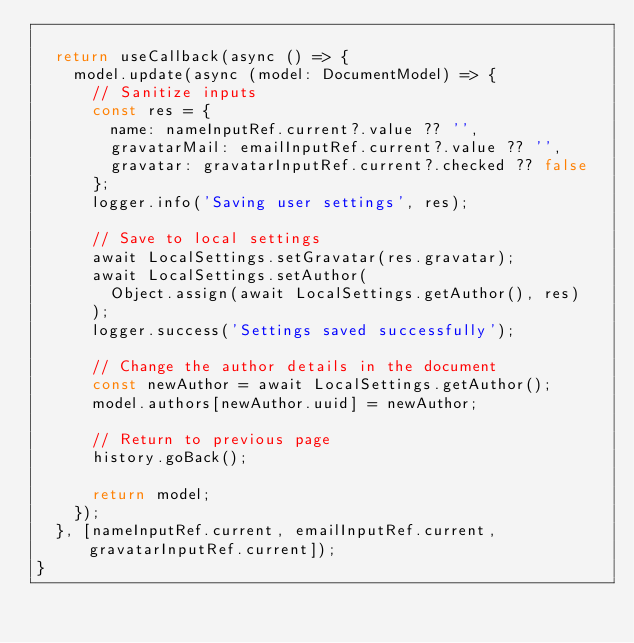<code> <loc_0><loc_0><loc_500><loc_500><_TypeScript_>
	return useCallback(async () => {
		model.update(async (model: DocumentModel) => {
			// Sanitize inputs
			const res = {
				name: nameInputRef.current?.value ?? '',
				gravatarMail: emailInputRef.current?.value ?? '',
				gravatar: gravatarInputRef.current?.checked ?? false
			};
			logger.info('Saving user settings', res);

			// Save to local settings
			await LocalSettings.setGravatar(res.gravatar);
			await LocalSettings.setAuthor(
				Object.assign(await LocalSettings.getAuthor(), res)
			);
			logger.success('Settings saved successfully');

			// Change the author details in the document
			const newAuthor = await LocalSettings.getAuthor();
			model.authors[newAuthor.uuid] = newAuthor;

			// Return to previous page
			history.goBack();

			return model;
		});
	}, [nameInputRef.current, emailInputRef.current, gravatarInputRef.current]);
}
</code> 